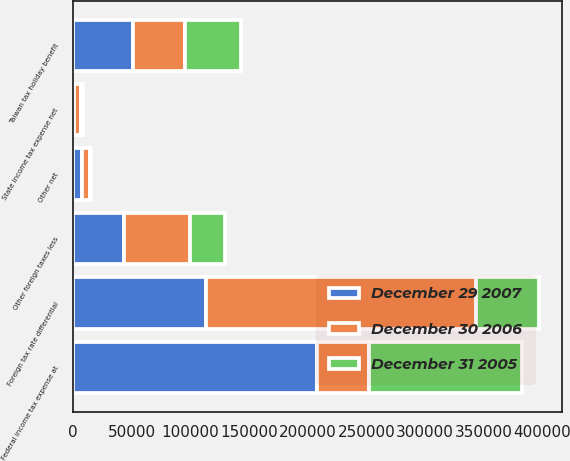Convert chart. <chart><loc_0><loc_0><loc_500><loc_500><stacked_bar_chart><ecel><fcel>Federal income tax expense at<fcel>State income tax expense net<fcel>Foreign tax rate differential<fcel>Taiwan tax holiday benefit<fcel>Other foreign taxes less<fcel>Other net<nl><fcel>December 30 2006<fcel>44128<fcel>5922<fcel>230243<fcel>44128<fcel>55983<fcel>6668<nl><fcel>December 29 2007<fcel>208094<fcel>658<fcel>112903<fcel>50905<fcel>43445<fcel>7958<nl><fcel>December 31 2005<fcel>130410<fcel>1666<fcel>53712<fcel>48175<fcel>30427<fcel>765<nl></chart> 